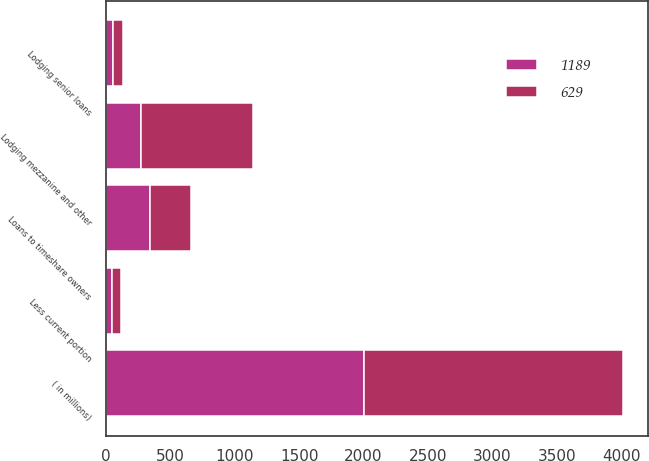<chart> <loc_0><loc_0><loc_500><loc_500><stacked_bar_chart><ecel><fcel>( in millions)<fcel>Loans to timeshare owners<fcel>Lodging senior loans<fcel>Lodging mezzanine and other<fcel>Less current portion<nl><fcel>1189<fcel>2005<fcel>344<fcel>59<fcel>274<fcel>48<nl><fcel>629<fcel>2004<fcel>315<fcel>75<fcel>867<fcel>68<nl></chart> 